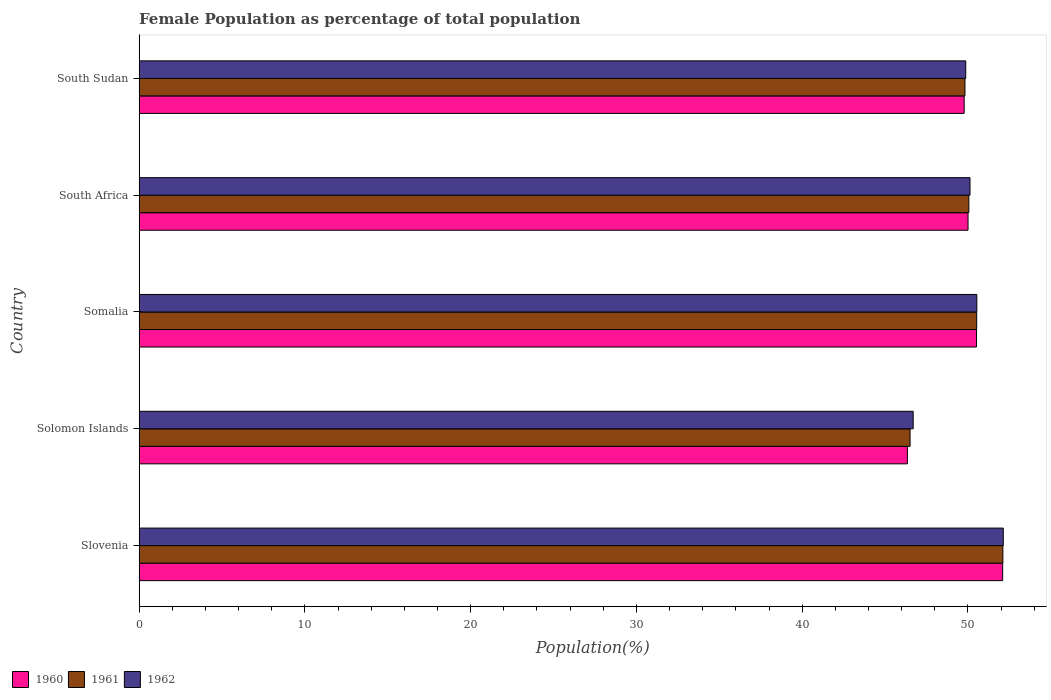How many different coloured bars are there?
Make the answer very short. 3. How many groups of bars are there?
Offer a very short reply. 5. Are the number of bars per tick equal to the number of legend labels?
Keep it short and to the point. Yes. How many bars are there on the 4th tick from the top?
Ensure brevity in your answer.  3. How many bars are there on the 3rd tick from the bottom?
Offer a terse response. 3. What is the label of the 2nd group of bars from the top?
Your response must be concise. South Africa. What is the female population in in 1960 in South Africa?
Offer a very short reply. 50.01. Across all countries, what is the maximum female population in in 1962?
Your answer should be compact. 52.13. Across all countries, what is the minimum female population in in 1962?
Offer a terse response. 46.7. In which country was the female population in in 1961 maximum?
Your answer should be very brief. Slovenia. In which country was the female population in in 1961 minimum?
Offer a very short reply. Solomon Islands. What is the total female population in in 1961 in the graph?
Provide a short and direct response. 249.02. What is the difference between the female population in in 1962 in Solomon Islands and that in Somalia?
Make the answer very short. -3.84. What is the difference between the female population in in 1962 in Solomon Islands and the female population in in 1960 in Slovenia?
Your answer should be compact. -5.4. What is the average female population in in 1962 per country?
Your answer should be compact. 49.87. What is the difference between the female population in in 1962 and female population in in 1960 in Somalia?
Ensure brevity in your answer.  0.02. What is the ratio of the female population in in 1961 in Somalia to that in South Africa?
Give a very brief answer. 1.01. What is the difference between the highest and the second highest female population in in 1960?
Keep it short and to the point. 1.58. What is the difference between the highest and the lowest female population in in 1961?
Your answer should be very brief. 5.6. Is the sum of the female population in in 1962 in Solomon Islands and Somalia greater than the maximum female population in in 1961 across all countries?
Your answer should be compact. Yes. How many bars are there?
Make the answer very short. 15. What is the difference between two consecutive major ticks on the X-axis?
Keep it short and to the point. 10. How many legend labels are there?
Your answer should be very brief. 3. How are the legend labels stacked?
Give a very brief answer. Horizontal. What is the title of the graph?
Provide a short and direct response. Female Population as percentage of total population. What is the label or title of the X-axis?
Make the answer very short. Population(%). What is the label or title of the Y-axis?
Keep it short and to the point. Country. What is the Population(%) of 1960 in Slovenia?
Make the answer very short. 52.1. What is the Population(%) of 1961 in Slovenia?
Your response must be concise. 52.11. What is the Population(%) in 1962 in Slovenia?
Your answer should be very brief. 52.13. What is the Population(%) of 1960 in Solomon Islands?
Your response must be concise. 46.35. What is the Population(%) of 1961 in Solomon Islands?
Make the answer very short. 46.51. What is the Population(%) in 1962 in Solomon Islands?
Your response must be concise. 46.7. What is the Population(%) of 1960 in Somalia?
Your answer should be very brief. 50.52. What is the Population(%) in 1961 in Somalia?
Offer a very short reply. 50.53. What is the Population(%) of 1962 in Somalia?
Your answer should be compact. 50.54. What is the Population(%) of 1960 in South Africa?
Make the answer very short. 50.01. What is the Population(%) of 1961 in South Africa?
Ensure brevity in your answer.  50.06. What is the Population(%) in 1962 in South Africa?
Keep it short and to the point. 50.12. What is the Population(%) in 1960 in South Sudan?
Ensure brevity in your answer.  49.77. What is the Population(%) of 1961 in South Sudan?
Your answer should be compact. 49.82. What is the Population(%) in 1962 in South Sudan?
Give a very brief answer. 49.87. Across all countries, what is the maximum Population(%) in 1960?
Ensure brevity in your answer.  52.1. Across all countries, what is the maximum Population(%) of 1961?
Keep it short and to the point. 52.11. Across all countries, what is the maximum Population(%) of 1962?
Ensure brevity in your answer.  52.13. Across all countries, what is the minimum Population(%) of 1960?
Ensure brevity in your answer.  46.35. Across all countries, what is the minimum Population(%) in 1961?
Keep it short and to the point. 46.51. Across all countries, what is the minimum Population(%) of 1962?
Make the answer very short. 46.7. What is the total Population(%) of 1960 in the graph?
Offer a terse response. 248.74. What is the total Population(%) of 1961 in the graph?
Your response must be concise. 249.02. What is the total Population(%) in 1962 in the graph?
Provide a succinct answer. 249.36. What is the difference between the Population(%) of 1960 in Slovenia and that in Solomon Islands?
Offer a terse response. 5.75. What is the difference between the Population(%) in 1961 in Slovenia and that in Solomon Islands?
Offer a terse response. 5.6. What is the difference between the Population(%) in 1962 in Slovenia and that in Solomon Islands?
Your response must be concise. 5.44. What is the difference between the Population(%) in 1960 in Slovenia and that in Somalia?
Give a very brief answer. 1.58. What is the difference between the Population(%) of 1961 in Slovenia and that in Somalia?
Offer a terse response. 1.58. What is the difference between the Population(%) in 1962 in Slovenia and that in Somalia?
Make the answer very short. 1.6. What is the difference between the Population(%) in 1960 in Slovenia and that in South Africa?
Make the answer very short. 2.09. What is the difference between the Population(%) in 1961 in Slovenia and that in South Africa?
Your answer should be very brief. 2.05. What is the difference between the Population(%) of 1962 in Slovenia and that in South Africa?
Offer a very short reply. 2.01. What is the difference between the Population(%) in 1960 in Slovenia and that in South Sudan?
Your answer should be compact. 2.32. What is the difference between the Population(%) of 1961 in Slovenia and that in South Sudan?
Give a very brief answer. 2.29. What is the difference between the Population(%) of 1962 in Slovenia and that in South Sudan?
Your answer should be very brief. 2.27. What is the difference between the Population(%) of 1960 in Solomon Islands and that in Somalia?
Your response must be concise. -4.17. What is the difference between the Population(%) of 1961 in Solomon Islands and that in Somalia?
Offer a terse response. -4.02. What is the difference between the Population(%) of 1962 in Solomon Islands and that in Somalia?
Your answer should be very brief. -3.84. What is the difference between the Population(%) in 1960 in Solomon Islands and that in South Africa?
Give a very brief answer. -3.66. What is the difference between the Population(%) of 1961 in Solomon Islands and that in South Africa?
Make the answer very short. -3.55. What is the difference between the Population(%) in 1962 in Solomon Islands and that in South Africa?
Provide a succinct answer. -3.43. What is the difference between the Population(%) in 1960 in Solomon Islands and that in South Sudan?
Offer a very short reply. -3.42. What is the difference between the Population(%) in 1961 in Solomon Islands and that in South Sudan?
Make the answer very short. -3.31. What is the difference between the Population(%) in 1962 in Solomon Islands and that in South Sudan?
Your response must be concise. -3.17. What is the difference between the Population(%) in 1960 in Somalia and that in South Africa?
Offer a very short reply. 0.51. What is the difference between the Population(%) of 1961 in Somalia and that in South Africa?
Provide a short and direct response. 0.47. What is the difference between the Population(%) of 1962 in Somalia and that in South Africa?
Provide a short and direct response. 0.41. What is the difference between the Population(%) of 1960 in Somalia and that in South Sudan?
Give a very brief answer. 0.75. What is the difference between the Population(%) of 1961 in Somalia and that in South Sudan?
Offer a very short reply. 0.71. What is the difference between the Population(%) in 1962 in Somalia and that in South Sudan?
Make the answer very short. 0.67. What is the difference between the Population(%) in 1960 in South Africa and that in South Sudan?
Provide a short and direct response. 0.23. What is the difference between the Population(%) of 1961 in South Africa and that in South Sudan?
Provide a short and direct response. 0.23. What is the difference between the Population(%) of 1962 in South Africa and that in South Sudan?
Your response must be concise. 0.26. What is the difference between the Population(%) in 1960 in Slovenia and the Population(%) in 1961 in Solomon Islands?
Offer a terse response. 5.59. What is the difference between the Population(%) in 1960 in Slovenia and the Population(%) in 1962 in Solomon Islands?
Keep it short and to the point. 5.4. What is the difference between the Population(%) of 1961 in Slovenia and the Population(%) of 1962 in Solomon Islands?
Keep it short and to the point. 5.41. What is the difference between the Population(%) in 1960 in Slovenia and the Population(%) in 1961 in Somalia?
Your answer should be compact. 1.57. What is the difference between the Population(%) in 1960 in Slovenia and the Population(%) in 1962 in Somalia?
Your response must be concise. 1.56. What is the difference between the Population(%) in 1961 in Slovenia and the Population(%) in 1962 in Somalia?
Ensure brevity in your answer.  1.57. What is the difference between the Population(%) of 1960 in Slovenia and the Population(%) of 1961 in South Africa?
Your answer should be very brief. 2.04. What is the difference between the Population(%) in 1960 in Slovenia and the Population(%) in 1962 in South Africa?
Keep it short and to the point. 1.97. What is the difference between the Population(%) of 1961 in Slovenia and the Population(%) of 1962 in South Africa?
Make the answer very short. 1.98. What is the difference between the Population(%) of 1960 in Slovenia and the Population(%) of 1961 in South Sudan?
Ensure brevity in your answer.  2.27. What is the difference between the Population(%) in 1960 in Slovenia and the Population(%) in 1962 in South Sudan?
Offer a very short reply. 2.23. What is the difference between the Population(%) in 1961 in Slovenia and the Population(%) in 1962 in South Sudan?
Offer a terse response. 2.24. What is the difference between the Population(%) in 1960 in Solomon Islands and the Population(%) in 1961 in Somalia?
Keep it short and to the point. -4.18. What is the difference between the Population(%) of 1960 in Solomon Islands and the Population(%) of 1962 in Somalia?
Provide a short and direct response. -4.19. What is the difference between the Population(%) of 1961 in Solomon Islands and the Population(%) of 1962 in Somalia?
Your answer should be compact. -4.03. What is the difference between the Population(%) of 1960 in Solomon Islands and the Population(%) of 1961 in South Africa?
Offer a very short reply. -3.71. What is the difference between the Population(%) in 1960 in Solomon Islands and the Population(%) in 1962 in South Africa?
Make the answer very short. -3.78. What is the difference between the Population(%) of 1961 in Solomon Islands and the Population(%) of 1962 in South Africa?
Keep it short and to the point. -3.62. What is the difference between the Population(%) of 1960 in Solomon Islands and the Population(%) of 1961 in South Sudan?
Provide a short and direct response. -3.47. What is the difference between the Population(%) in 1960 in Solomon Islands and the Population(%) in 1962 in South Sudan?
Ensure brevity in your answer.  -3.52. What is the difference between the Population(%) in 1961 in Solomon Islands and the Population(%) in 1962 in South Sudan?
Give a very brief answer. -3.36. What is the difference between the Population(%) of 1960 in Somalia and the Population(%) of 1961 in South Africa?
Make the answer very short. 0.46. What is the difference between the Population(%) in 1960 in Somalia and the Population(%) in 1962 in South Africa?
Give a very brief answer. 0.39. What is the difference between the Population(%) of 1961 in Somalia and the Population(%) of 1962 in South Africa?
Provide a short and direct response. 0.4. What is the difference between the Population(%) of 1960 in Somalia and the Population(%) of 1961 in South Sudan?
Offer a very short reply. 0.7. What is the difference between the Population(%) of 1960 in Somalia and the Population(%) of 1962 in South Sudan?
Make the answer very short. 0.65. What is the difference between the Population(%) in 1961 in Somalia and the Population(%) in 1962 in South Sudan?
Your answer should be very brief. 0.66. What is the difference between the Population(%) in 1960 in South Africa and the Population(%) in 1961 in South Sudan?
Offer a very short reply. 0.18. What is the difference between the Population(%) of 1960 in South Africa and the Population(%) of 1962 in South Sudan?
Your answer should be very brief. 0.14. What is the difference between the Population(%) of 1961 in South Africa and the Population(%) of 1962 in South Sudan?
Keep it short and to the point. 0.19. What is the average Population(%) of 1960 per country?
Offer a very short reply. 49.75. What is the average Population(%) of 1961 per country?
Ensure brevity in your answer.  49.8. What is the average Population(%) in 1962 per country?
Your answer should be compact. 49.87. What is the difference between the Population(%) of 1960 and Population(%) of 1961 in Slovenia?
Your answer should be compact. -0.01. What is the difference between the Population(%) in 1960 and Population(%) in 1962 in Slovenia?
Offer a terse response. -0.04. What is the difference between the Population(%) in 1961 and Population(%) in 1962 in Slovenia?
Offer a terse response. -0.02. What is the difference between the Population(%) of 1960 and Population(%) of 1961 in Solomon Islands?
Your response must be concise. -0.16. What is the difference between the Population(%) in 1960 and Population(%) in 1962 in Solomon Islands?
Ensure brevity in your answer.  -0.35. What is the difference between the Population(%) of 1961 and Population(%) of 1962 in Solomon Islands?
Offer a terse response. -0.19. What is the difference between the Population(%) of 1960 and Population(%) of 1961 in Somalia?
Ensure brevity in your answer.  -0.01. What is the difference between the Population(%) of 1960 and Population(%) of 1962 in Somalia?
Keep it short and to the point. -0.02. What is the difference between the Population(%) in 1961 and Population(%) in 1962 in Somalia?
Offer a terse response. -0.01. What is the difference between the Population(%) in 1960 and Population(%) in 1961 in South Africa?
Ensure brevity in your answer.  -0.05. What is the difference between the Population(%) of 1960 and Population(%) of 1962 in South Africa?
Ensure brevity in your answer.  -0.12. What is the difference between the Population(%) of 1961 and Population(%) of 1962 in South Africa?
Ensure brevity in your answer.  -0.07. What is the difference between the Population(%) in 1960 and Population(%) in 1961 in South Sudan?
Provide a succinct answer. -0.05. What is the difference between the Population(%) in 1960 and Population(%) in 1962 in South Sudan?
Your response must be concise. -0.1. What is the difference between the Population(%) in 1961 and Population(%) in 1962 in South Sudan?
Make the answer very short. -0.05. What is the ratio of the Population(%) of 1960 in Slovenia to that in Solomon Islands?
Give a very brief answer. 1.12. What is the ratio of the Population(%) in 1961 in Slovenia to that in Solomon Islands?
Make the answer very short. 1.12. What is the ratio of the Population(%) in 1962 in Slovenia to that in Solomon Islands?
Make the answer very short. 1.12. What is the ratio of the Population(%) of 1960 in Slovenia to that in Somalia?
Offer a terse response. 1.03. What is the ratio of the Population(%) in 1961 in Slovenia to that in Somalia?
Provide a succinct answer. 1.03. What is the ratio of the Population(%) of 1962 in Slovenia to that in Somalia?
Make the answer very short. 1.03. What is the ratio of the Population(%) of 1960 in Slovenia to that in South Africa?
Provide a short and direct response. 1.04. What is the ratio of the Population(%) in 1961 in Slovenia to that in South Africa?
Give a very brief answer. 1.04. What is the ratio of the Population(%) of 1962 in Slovenia to that in South Africa?
Your answer should be compact. 1.04. What is the ratio of the Population(%) in 1960 in Slovenia to that in South Sudan?
Give a very brief answer. 1.05. What is the ratio of the Population(%) of 1961 in Slovenia to that in South Sudan?
Your answer should be very brief. 1.05. What is the ratio of the Population(%) in 1962 in Slovenia to that in South Sudan?
Ensure brevity in your answer.  1.05. What is the ratio of the Population(%) of 1960 in Solomon Islands to that in Somalia?
Provide a short and direct response. 0.92. What is the ratio of the Population(%) in 1961 in Solomon Islands to that in Somalia?
Your answer should be compact. 0.92. What is the ratio of the Population(%) in 1962 in Solomon Islands to that in Somalia?
Make the answer very short. 0.92. What is the ratio of the Population(%) of 1960 in Solomon Islands to that in South Africa?
Your response must be concise. 0.93. What is the ratio of the Population(%) in 1961 in Solomon Islands to that in South Africa?
Keep it short and to the point. 0.93. What is the ratio of the Population(%) of 1962 in Solomon Islands to that in South Africa?
Ensure brevity in your answer.  0.93. What is the ratio of the Population(%) in 1960 in Solomon Islands to that in South Sudan?
Keep it short and to the point. 0.93. What is the ratio of the Population(%) in 1961 in Solomon Islands to that in South Sudan?
Keep it short and to the point. 0.93. What is the ratio of the Population(%) of 1962 in Solomon Islands to that in South Sudan?
Keep it short and to the point. 0.94. What is the ratio of the Population(%) of 1960 in Somalia to that in South Africa?
Give a very brief answer. 1.01. What is the ratio of the Population(%) of 1961 in Somalia to that in South Africa?
Make the answer very short. 1.01. What is the ratio of the Population(%) of 1962 in Somalia to that in South Africa?
Your answer should be very brief. 1.01. What is the ratio of the Population(%) in 1961 in Somalia to that in South Sudan?
Make the answer very short. 1.01. What is the ratio of the Population(%) in 1962 in Somalia to that in South Sudan?
Your answer should be very brief. 1.01. What is the difference between the highest and the second highest Population(%) of 1960?
Provide a succinct answer. 1.58. What is the difference between the highest and the second highest Population(%) in 1961?
Provide a short and direct response. 1.58. What is the difference between the highest and the second highest Population(%) in 1962?
Provide a short and direct response. 1.6. What is the difference between the highest and the lowest Population(%) of 1960?
Make the answer very short. 5.75. What is the difference between the highest and the lowest Population(%) of 1961?
Your answer should be compact. 5.6. What is the difference between the highest and the lowest Population(%) of 1962?
Your answer should be very brief. 5.44. 